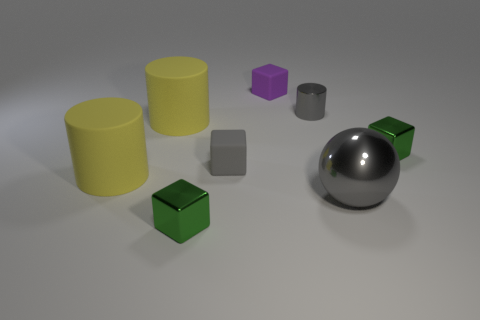How many yellow cylinders must be subtracted to get 1 yellow cylinders? 1 Subtract all small gray shiny cylinders. How many cylinders are left? 2 Subtract all purple cubes. How many cubes are left? 3 Add 2 brown rubber objects. How many objects exist? 10 Subtract all brown spheres. How many green cubes are left? 2 Subtract all balls. How many objects are left? 7 Subtract 1 gray spheres. How many objects are left? 7 Subtract 3 cylinders. How many cylinders are left? 0 Subtract all blue blocks. Subtract all yellow cylinders. How many blocks are left? 4 Subtract all matte cylinders. Subtract all gray matte objects. How many objects are left? 5 